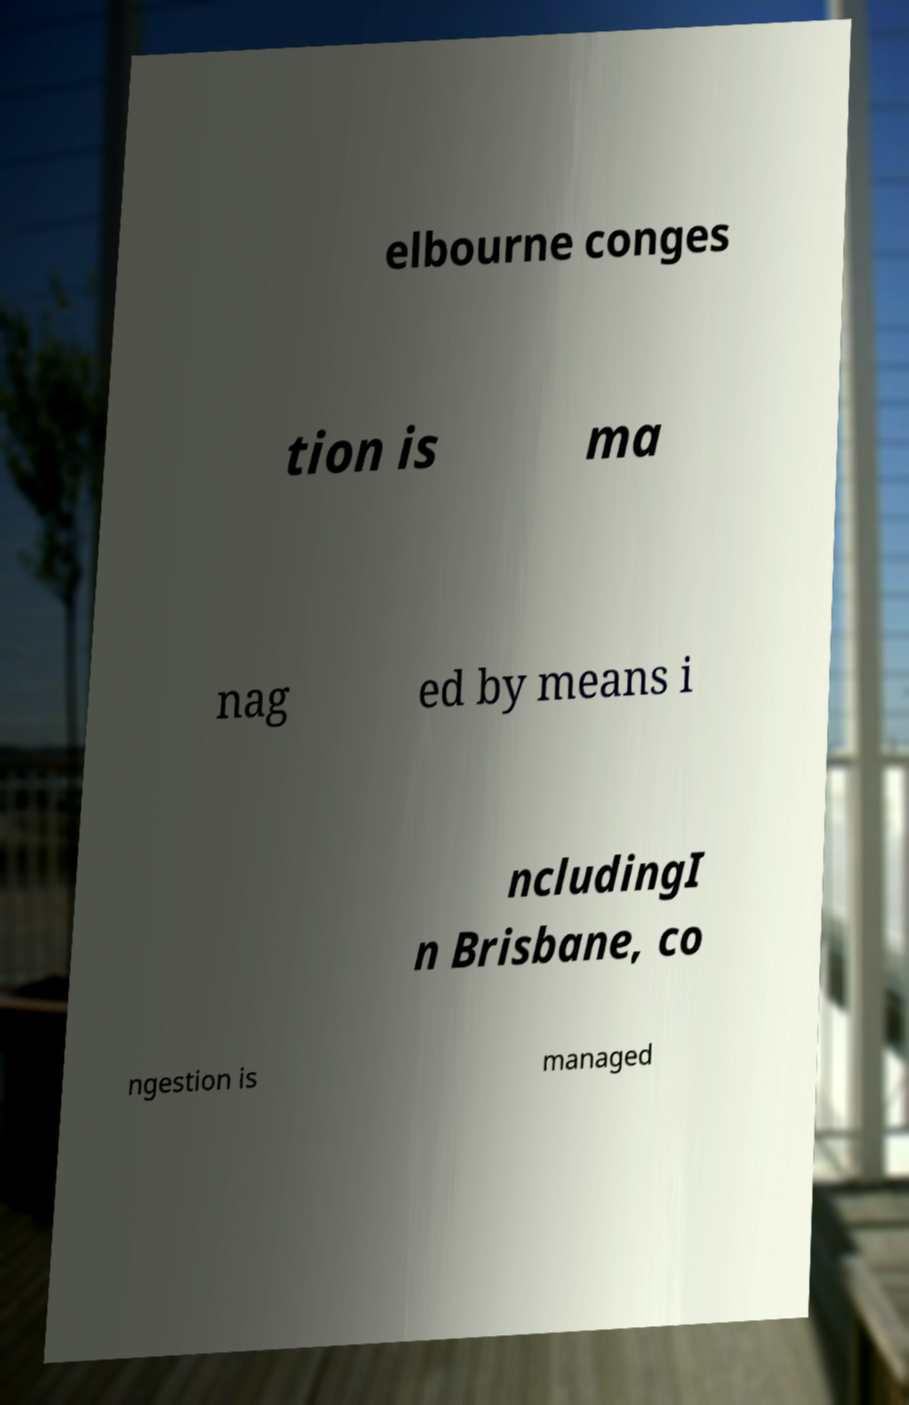Could you assist in decoding the text presented in this image and type it out clearly? elbourne conges tion is ma nag ed by means i ncludingI n Brisbane, co ngestion is managed 